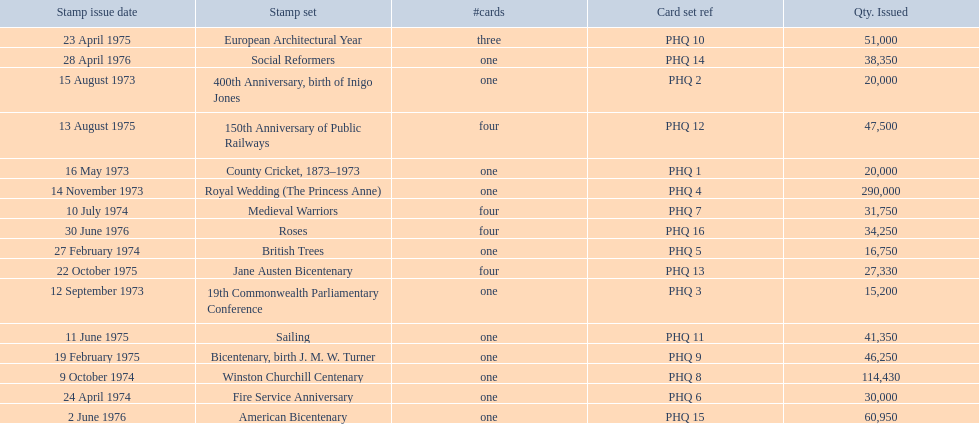What are all of the stamp sets? County Cricket, 1873–1973, 400th Anniversary, birth of Inigo Jones, 19th Commonwealth Parliamentary Conference, Royal Wedding (The Princess Anne), British Trees, Fire Service Anniversary, Medieval Warriors, Winston Churchill Centenary, Bicentenary, birth J. M. W. Turner, European Architectural Year, Sailing, 150th Anniversary of Public Railways, Jane Austen Bicentenary, Social Reformers, American Bicentenary, Roses. Which of these sets has three cards in it? European Architectural Year. 